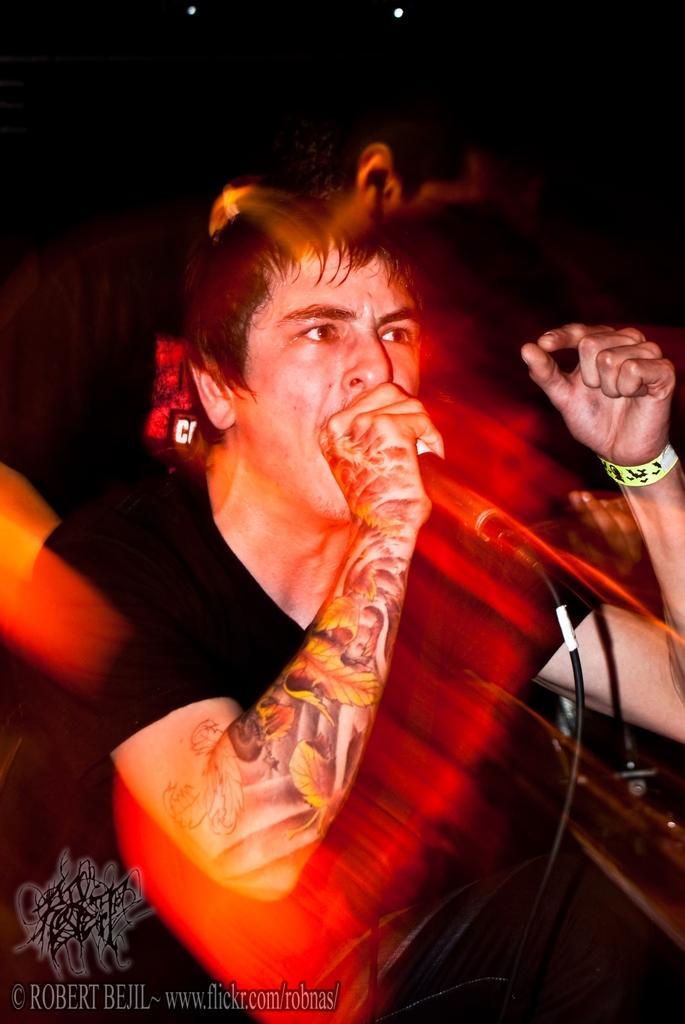Describe this image in one or two sentences. In this picture there is a man who is singing on the mic. He is wearing t-shirt and band. At the bottom there is a watermark. At the top we can see the lights and darkness. 